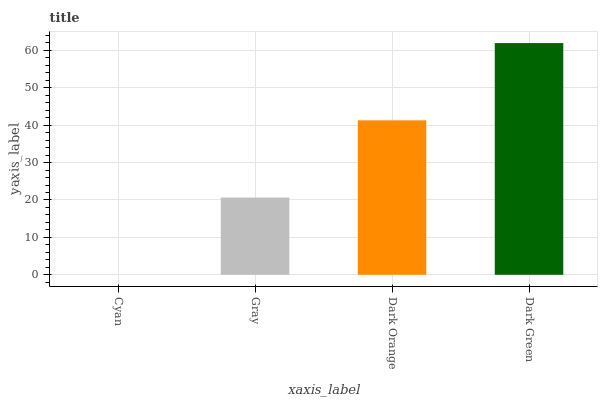Is Cyan the minimum?
Answer yes or no. Yes. Is Dark Green the maximum?
Answer yes or no. Yes. Is Gray the minimum?
Answer yes or no. No. Is Gray the maximum?
Answer yes or no. No. Is Gray greater than Cyan?
Answer yes or no. Yes. Is Cyan less than Gray?
Answer yes or no. Yes. Is Cyan greater than Gray?
Answer yes or no. No. Is Gray less than Cyan?
Answer yes or no. No. Is Dark Orange the high median?
Answer yes or no. Yes. Is Gray the low median?
Answer yes or no. Yes. Is Dark Green the high median?
Answer yes or no. No. Is Dark Orange the low median?
Answer yes or no. No. 